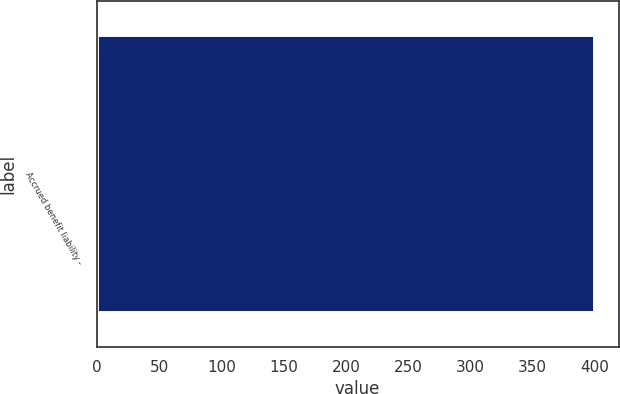<chart> <loc_0><loc_0><loc_500><loc_500><bar_chart><fcel>Accrued benefit liability -<nl><fcel>399<nl></chart> 